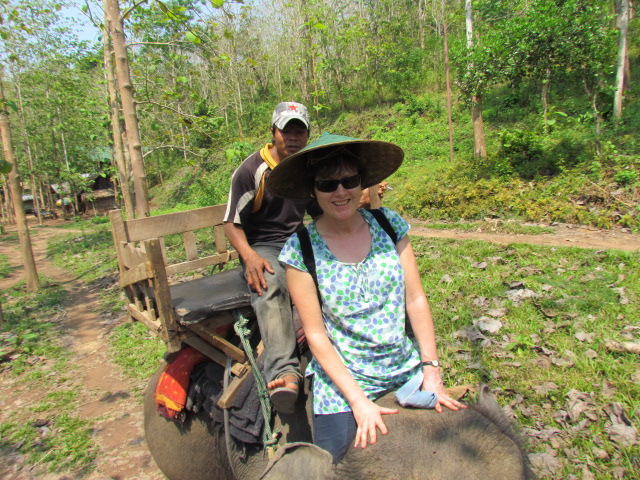<image>What type of hat is the woman wearing? I am not sure about the type of hat the woman is wearing. It can be a sun hat, an Asian conical hat, a Japanese hat or a Vietnamese hat. What type of hat is the woman wearing? The woman is wearing an asian conical hat. 